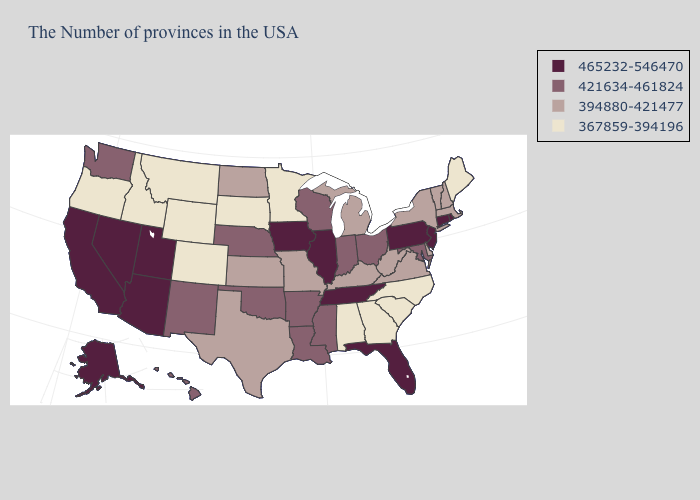What is the value of Washington?
Give a very brief answer. 421634-461824. Among the states that border Tennessee , which have the highest value?
Give a very brief answer. Mississippi, Arkansas. What is the value of North Dakota?
Keep it brief. 394880-421477. What is the lowest value in states that border Wyoming?
Short answer required. 367859-394196. Name the states that have a value in the range 465232-546470?
Give a very brief answer. Rhode Island, Connecticut, New Jersey, Pennsylvania, Florida, Tennessee, Illinois, Iowa, Utah, Arizona, Nevada, California, Alaska. What is the highest value in the USA?
Answer briefly. 465232-546470. Name the states that have a value in the range 394880-421477?
Give a very brief answer. Massachusetts, New Hampshire, Vermont, New York, Delaware, Virginia, West Virginia, Michigan, Kentucky, Missouri, Kansas, Texas, North Dakota. What is the value of Illinois?
Give a very brief answer. 465232-546470. What is the value of Hawaii?
Give a very brief answer. 421634-461824. What is the value of West Virginia?
Short answer required. 394880-421477. Which states have the lowest value in the MidWest?
Answer briefly. Minnesota, South Dakota. Does Hawaii have a lower value than Maine?
Give a very brief answer. No. What is the lowest value in states that border Indiana?
Quick response, please. 394880-421477. Among the states that border Colorado , which have the lowest value?
Be succinct. Wyoming. Name the states that have a value in the range 394880-421477?
Keep it brief. Massachusetts, New Hampshire, Vermont, New York, Delaware, Virginia, West Virginia, Michigan, Kentucky, Missouri, Kansas, Texas, North Dakota. 